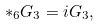<formula> <loc_0><loc_0><loc_500><loc_500>* _ { 6 } G _ { 3 } = i G _ { 3 } ,</formula> 